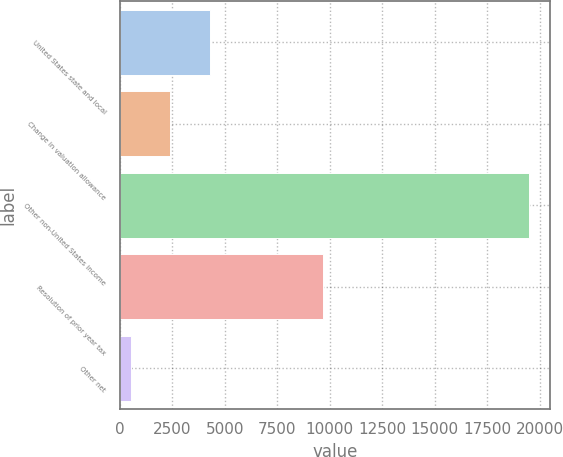<chart> <loc_0><loc_0><loc_500><loc_500><bar_chart><fcel>United States state and local<fcel>Change in valuation allowance<fcel>Other non-United States income<fcel>Resolution of prior year tax<fcel>Other net<nl><fcel>4309.4<fcel>2410.7<fcel>19499<fcel>9681<fcel>512<nl></chart> 